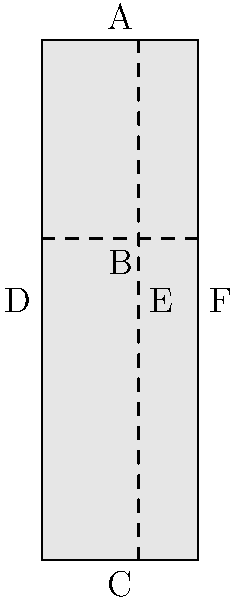In a traditional mezuzah scroll case designed according to the golden ratio, the case is divided into two sections as shown in the diagram. If the total length of the case is 10 cm, what is the length of the shorter section (B to C) to the nearest millimeter? To solve this problem, we need to understand the golden ratio and apply it to the mezuzah case dimensions:

1. The golden ratio, denoted by $\phi$ (phi), is approximately equal to 1.618.
2. In a golden ratio division, the ratio of the whole to the larger part is equal to the ratio of the larger part to the smaller part.
3. Let's denote the total length as L (10 cm) and the length of the longer section as x.

We can set up the following equation:

$$ \frac{L}{x} = \frac{x}{L-x} = \phi $$

4. Substituting the known values:

$$ \frac{10}{x} = \frac{x}{10-x} = \phi $$

5. We can simplify this to:

$$ x^2 = 10(10-x) $$
$$ x^2 = 100 - 10x $$
$$ x^2 + 10x - 100 = 0 $$

6. This is a quadratic equation. We can solve it using the quadratic formula:

$$ x = \frac{-b \pm \sqrt{b^2 - 4ac}}{2a} $$

Where $a=1$, $b=10$, and $c=-100$

7. Solving this equation:

$$ x = \frac{-10 \pm \sqrt{100 + 400}}{2} = \frac{-10 \pm \sqrt{500}}{2} $$

8. Taking the positive root (as length cannot be negative):

$$ x = \frac{-10 + \sqrt{500}}{2} \approx 6.18 cm $$

9. The shorter section (B to C) is therefore:

$$ 10 - 6.18 = 3.82 cm $$

10. Rounding to the nearest millimeter:

$$ 3.82 cm \approx 3.8 cm $$
Answer: 3.8 cm 